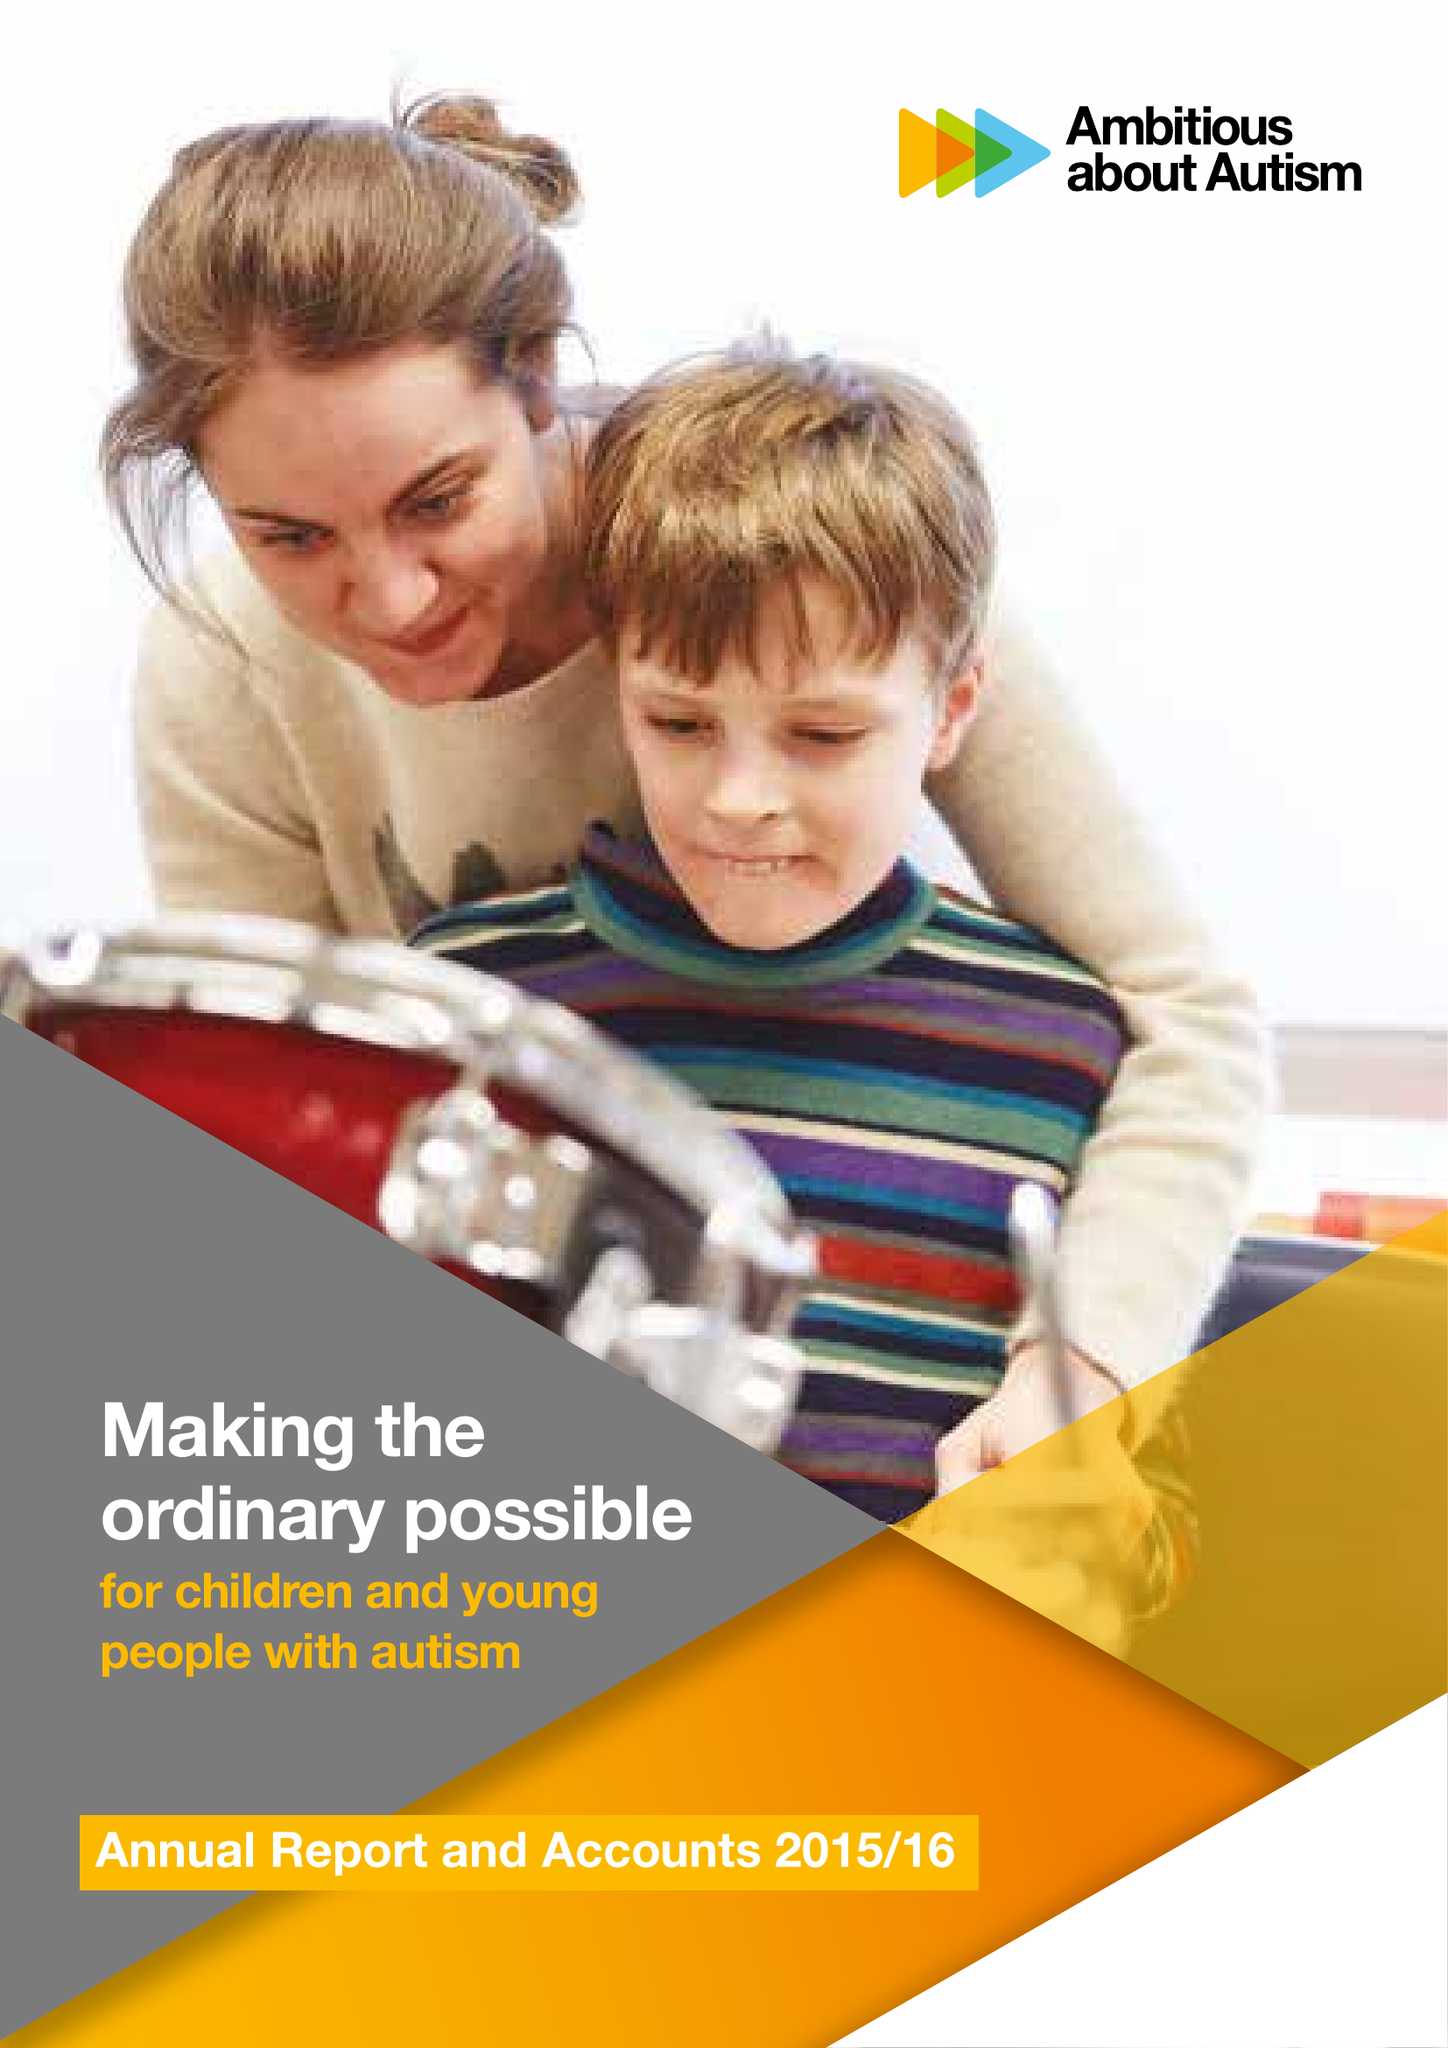What is the value for the charity_number?
Answer the question using a single word or phrase. 1063184 